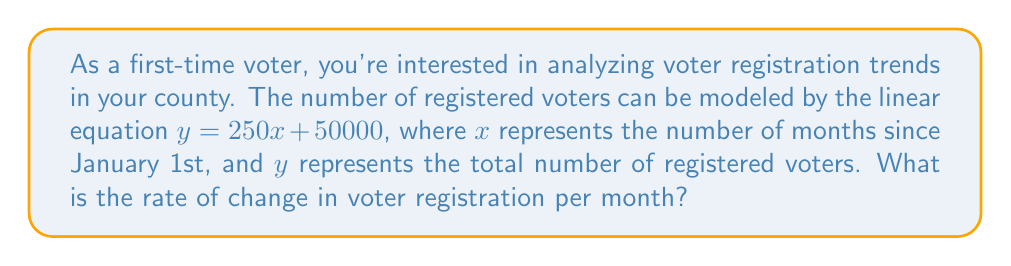Could you help me with this problem? To find the rate of change in voter registration per month, we need to analyze the given linear equation:

$y = 250x + 50000$

In a linear equation of the form $y = mx + b$:
- $m$ represents the slope of the line, which is the rate of change
- $x$ is the independent variable (months in this case)
- $b$ is the y-intercept

In our equation:
$y = 250x + 50000$

Comparing this to the standard form $y = mx + b$, we can see that:
$m = 250$

The slope $m$ represents the rate of change in the dependent variable ($y$) for each unit increase in the independent variable ($x$).

Since $x$ represents months and $y$ represents the number of registered voters, the slope $m = 250$ indicates that the number of registered voters increases by 250 for each month that passes.

Therefore, the rate of change in voter registration is 250 voters per month.
Answer: 250 voters/month 